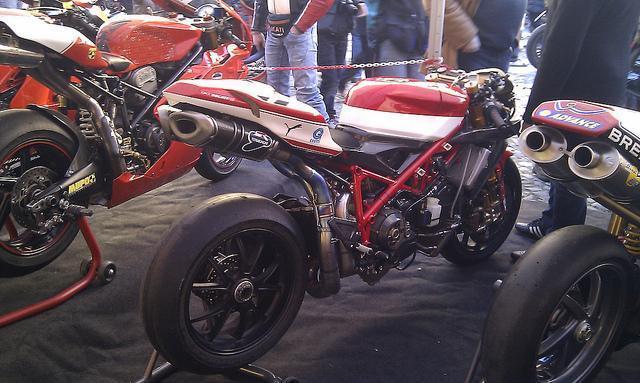How many bikes are visible?
Give a very brief answer. 3. How many people are in the picture?
Give a very brief answer. 5. How many motorcycles are in the picture?
Give a very brief answer. 3. 